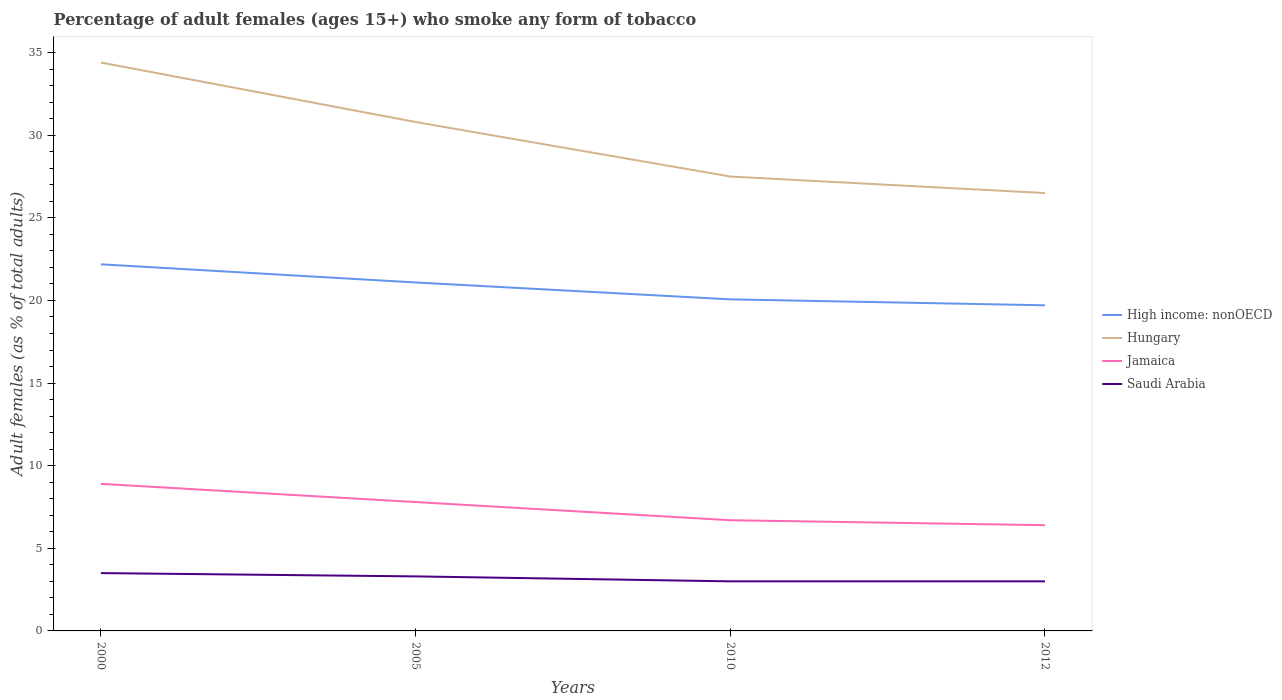Across all years, what is the maximum percentage of adult females who smoke in Jamaica?
Keep it short and to the point. 6.4. In which year was the percentage of adult females who smoke in Saudi Arabia maximum?
Make the answer very short. 2010. What is the total percentage of adult females who smoke in Jamaica in the graph?
Offer a terse response. 0.3. What is the difference between the highest and the lowest percentage of adult females who smoke in High income: nonOECD?
Offer a terse response. 2. Is the percentage of adult females who smoke in High income: nonOECD strictly greater than the percentage of adult females who smoke in Saudi Arabia over the years?
Offer a very short reply. No. How many lines are there?
Provide a short and direct response. 4. What is the difference between two consecutive major ticks on the Y-axis?
Provide a short and direct response. 5. Does the graph contain grids?
Make the answer very short. No. Where does the legend appear in the graph?
Your answer should be compact. Center right. What is the title of the graph?
Keep it short and to the point. Percentage of adult females (ages 15+) who smoke any form of tobacco. What is the label or title of the X-axis?
Your answer should be very brief. Years. What is the label or title of the Y-axis?
Provide a succinct answer. Adult females (as % of total adults). What is the Adult females (as % of total adults) in High income: nonOECD in 2000?
Offer a terse response. 22.19. What is the Adult females (as % of total adults) of Hungary in 2000?
Offer a terse response. 34.4. What is the Adult females (as % of total adults) of Jamaica in 2000?
Give a very brief answer. 8.9. What is the Adult females (as % of total adults) in Saudi Arabia in 2000?
Offer a terse response. 3.5. What is the Adult females (as % of total adults) in High income: nonOECD in 2005?
Ensure brevity in your answer.  21.09. What is the Adult females (as % of total adults) of Hungary in 2005?
Your response must be concise. 30.8. What is the Adult females (as % of total adults) in Jamaica in 2005?
Offer a very short reply. 7.8. What is the Adult females (as % of total adults) in Saudi Arabia in 2005?
Provide a succinct answer. 3.3. What is the Adult females (as % of total adults) in High income: nonOECD in 2010?
Provide a succinct answer. 20.07. What is the Adult females (as % of total adults) in High income: nonOECD in 2012?
Keep it short and to the point. 19.71. What is the Adult females (as % of total adults) of Hungary in 2012?
Your answer should be very brief. 26.5. What is the Adult females (as % of total adults) of Saudi Arabia in 2012?
Offer a very short reply. 3. Across all years, what is the maximum Adult females (as % of total adults) in High income: nonOECD?
Your response must be concise. 22.19. Across all years, what is the maximum Adult females (as % of total adults) in Hungary?
Ensure brevity in your answer.  34.4. Across all years, what is the maximum Adult females (as % of total adults) in Saudi Arabia?
Make the answer very short. 3.5. Across all years, what is the minimum Adult females (as % of total adults) of High income: nonOECD?
Your response must be concise. 19.71. Across all years, what is the minimum Adult females (as % of total adults) in Jamaica?
Give a very brief answer. 6.4. What is the total Adult females (as % of total adults) of High income: nonOECD in the graph?
Your answer should be compact. 83.05. What is the total Adult females (as % of total adults) in Hungary in the graph?
Your response must be concise. 119.2. What is the total Adult females (as % of total adults) of Jamaica in the graph?
Give a very brief answer. 29.8. What is the difference between the Adult females (as % of total adults) of High income: nonOECD in 2000 and that in 2005?
Offer a very short reply. 1.1. What is the difference between the Adult females (as % of total adults) of Saudi Arabia in 2000 and that in 2005?
Offer a very short reply. 0.2. What is the difference between the Adult females (as % of total adults) of High income: nonOECD in 2000 and that in 2010?
Make the answer very short. 2.12. What is the difference between the Adult females (as % of total adults) in Hungary in 2000 and that in 2010?
Give a very brief answer. 6.9. What is the difference between the Adult females (as % of total adults) in Jamaica in 2000 and that in 2010?
Offer a terse response. 2.2. What is the difference between the Adult females (as % of total adults) in Saudi Arabia in 2000 and that in 2010?
Give a very brief answer. 0.5. What is the difference between the Adult females (as % of total adults) in High income: nonOECD in 2000 and that in 2012?
Give a very brief answer. 2.48. What is the difference between the Adult females (as % of total adults) in High income: nonOECD in 2005 and that in 2010?
Provide a short and direct response. 1.02. What is the difference between the Adult females (as % of total adults) of Jamaica in 2005 and that in 2010?
Provide a short and direct response. 1.1. What is the difference between the Adult females (as % of total adults) in High income: nonOECD in 2005 and that in 2012?
Your answer should be very brief. 1.38. What is the difference between the Adult females (as % of total adults) of High income: nonOECD in 2010 and that in 2012?
Your answer should be compact. 0.36. What is the difference between the Adult females (as % of total adults) in Hungary in 2010 and that in 2012?
Make the answer very short. 1. What is the difference between the Adult females (as % of total adults) of Jamaica in 2010 and that in 2012?
Offer a terse response. 0.3. What is the difference between the Adult females (as % of total adults) of High income: nonOECD in 2000 and the Adult females (as % of total adults) of Hungary in 2005?
Provide a succinct answer. -8.61. What is the difference between the Adult females (as % of total adults) in High income: nonOECD in 2000 and the Adult females (as % of total adults) in Jamaica in 2005?
Keep it short and to the point. 14.39. What is the difference between the Adult females (as % of total adults) in High income: nonOECD in 2000 and the Adult females (as % of total adults) in Saudi Arabia in 2005?
Your response must be concise. 18.89. What is the difference between the Adult females (as % of total adults) of Hungary in 2000 and the Adult females (as % of total adults) of Jamaica in 2005?
Offer a terse response. 26.6. What is the difference between the Adult females (as % of total adults) in Hungary in 2000 and the Adult females (as % of total adults) in Saudi Arabia in 2005?
Provide a succinct answer. 31.1. What is the difference between the Adult females (as % of total adults) of Jamaica in 2000 and the Adult females (as % of total adults) of Saudi Arabia in 2005?
Your answer should be very brief. 5.6. What is the difference between the Adult females (as % of total adults) in High income: nonOECD in 2000 and the Adult females (as % of total adults) in Hungary in 2010?
Provide a short and direct response. -5.31. What is the difference between the Adult females (as % of total adults) in High income: nonOECD in 2000 and the Adult females (as % of total adults) in Jamaica in 2010?
Make the answer very short. 15.49. What is the difference between the Adult females (as % of total adults) in High income: nonOECD in 2000 and the Adult females (as % of total adults) in Saudi Arabia in 2010?
Provide a short and direct response. 19.19. What is the difference between the Adult females (as % of total adults) in Hungary in 2000 and the Adult females (as % of total adults) in Jamaica in 2010?
Make the answer very short. 27.7. What is the difference between the Adult females (as % of total adults) in Hungary in 2000 and the Adult females (as % of total adults) in Saudi Arabia in 2010?
Your answer should be very brief. 31.4. What is the difference between the Adult females (as % of total adults) in Jamaica in 2000 and the Adult females (as % of total adults) in Saudi Arabia in 2010?
Give a very brief answer. 5.9. What is the difference between the Adult females (as % of total adults) in High income: nonOECD in 2000 and the Adult females (as % of total adults) in Hungary in 2012?
Give a very brief answer. -4.31. What is the difference between the Adult females (as % of total adults) in High income: nonOECD in 2000 and the Adult females (as % of total adults) in Jamaica in 2012?
Your answer should be very brief. 15.79. What is the difference between the Adult females (as % of total adults) of High income: nonOECD in 2000 and the Adult females (as % of total adults) of Saudi Arabia in 2012?
Make the answer very short. 19.19. What is the difference between the Adult females (as % of total adults) in Hungary in 2000 and the Adult females (as % of total adults) in Jamaica in 2012?
Your answer should be compact. 28. What is the difference between the Adult females (as % of total adults) of Hungary in 2000 and the Adult females (as % of total adults) of Saudi Arabia in 2012?
Give a very brief answer. 31.4. What is the difference between the Adult females (as % of total adults) of High income: nonOECD in 2005 and the Adult females (as % of total adults) of Hungary in 2010?
Keep it short and to the point. -6.41. What is the difference between the Adult females (as % of total adults) in High income: nonOECD in 2005 and the Adult females (as % of total adults) in Jamaica in 2010?
Your answer should be compact. 14.39. What is the difference between the Adult females (as % of total adults) of High income: nonOECD in 2005 and the Adult females (as % of total adults) of Saudi Arabia in 2010?
Your answer should be very brief. 18.09. What is the difference between the Adult females (as % of total adults) in Hungary in 2005 and the Adult females (as % of total adults) in Jamaica in 2010?
Give a very brief answer. 24.1. What is the difference between the Adult females (as % of total adults) of Hungary in 2005 and the Adult females (as % of total adults) of Saudi Arabia in 2010?
Offer a very short reply. 27.8. What is the difference between the Adult females (as % of total adults) of High income: nonOECD in 2005 and the Adult females (as % of total adults) of Hungary in 2012?
Offer a very short reply. -5.41. What is the difference between the Adult females (as % of total adults) in High income: nonOECD in 2005 and the Adult females (as % of total adults) in Jamaica in 2012?
Provide a short and direct response. 14.69. What is the difference between the Adult females (as % of total adults) of High income: nonOECD in 2005 and the Adult females (as % of total adults) of Saudi Arabia in 2012?
Offer a very short reply. 18.09. What is the difference between the Adult females (as % of total adults) in Hungary in 2005 and the Adult females (as % of total adults) in Jamaica in 2012?
Ensure brevity in your answer.  24.4. What is the difference between the Adult females (as % of total adults) of Hungary in 2005 and the Adult females (as % of total adults) of Saudi Arabia in 2012?
Give a very brief answer. 27.8. What is the difference between the Adult females (as % of total adults) of High income: nonOECD in 2010 and the Adult females (as % of total adults) of Hungary in 2012?
Give a very brief answer. -6.43. What is the difference between the Adult females (as % of total adults) in High income: nonOECD in 2010 and the Adult females (as % of total adults) in Jamaica in 2012?
Provide a short and direct response. 13.67. What is the difference between the Adult females (as % of total adults) in High income: nonOECD in 2010 and the Adult females (as % of total adults) in Saudi Arabia in 2012?
Give a very brief answer. 17.07. What is the difference between the Adult females (as % of total adults) of Hungary in 2010 and the Adult females (as % of total adults) of Jamaica in 2012?
Offer a terse response. 21.1. What is the difference between the Adult females (as % of total adults) of Hungary in 2010 and the Adult females (as % of total adults) of Saudi Arabia in 2012?
Give a very brief answer. 24.5. What is the difference between the Adult females (as % of total adults) in Jamaica in 2010 and the Adult females (as % of total adults) in Saudi Arabia in 2012?
Ensure brevity in your answer.  3.7. What is the average Adult females (as % of total adults) of High income: nonOECD per year?
Give a very brief answer. 20.76. What is the average Adult females (as % of total adults) in Hungary per year?
Ensure brevity in your answer.  29.8. What is the average Adult females (as % of total adults) in Jamaica per year?
Provide a short and direct response. 7.45. In the year 2000, what is the difference between the Adult females (as % of total adults) in High income: nonOECD and Adult females (as % of total adults) in Hungary?
Your response must be concise. -12.21. In the year 2000, what is the difference between the Adult females (as % of total adults) in High income: nonOECD and Adult females (as % of total adults) in Jamaica?
Provide a short and direct response. 13.29. In the year 2000, what is the difference between the Adult females (as % of total adults) of High income: nonOECD and Adult females (as % of total adults) of Saudi Arabia?
Provide a short and direct response. 18.69. In the year 2000, what is the difference between the Adult females (as % of total adults) of Hungary and Adult females (as % of total adults) of Saudi Arabia?
Offer a very short reply. 30.9. In the year 2000, what is the difference between the Adult females (as % of total adults) in Jamaica and Adult females (as % of total adults) in Saudi Arabia?
Offer a terse response. 5.4. In the year 2005, what is the difference between the Adult females (as % of total adults) of High income: nonOECD and Adult females (as % of total adults) of Hungary?
Keep it short and to the point. -9.71. In the year 2005, what is the difference between the Adult females (as % of total adults) of High income: nonOECD and Adult females (as % of total adults) of Jamaica?
Give a very brief answer. 13.29. In the year 2005, what is the difference between the Adult females (as % of total adults) in High income: nonOECD and Adult females (as % of total adults) in Saudi Arabia?
Provide a short and direct response. 17.79. In the year 2010, what is the difference between the Adult females (as % of total adults) of High income: nonOECD and Adult females (as % of total adults) of Hungary?
Ensure brevity in your answer.  -7.43. In the year 2010, what is the difference between the Adult females (as % of total adults) in High income: nonOECD and Adult females (as % of total adults) in Jamaica?
Your response must be concise. 13.37. In the year 2010, what is the difference between the Adult females (as % of total adults) of High income: nonOECD and Adult females (as % of total adults) of Saudi Arabia?
Give a very brief answer. 17.07. In the year 2010, what is the difference between the Adult females (as % of total adults) in Hungary and Adult females (as % of total adults) in Jamaica?
Offer a very short reply. 20.8. In the year 2010, what is the difference between the Adult females (as % of total adults) in Jamaica and Adult females (as % of total adults) in Saudi Arabia?
Provide a succinct answer. 3.7. In the year 2012, what is the difference between the Adult females (as % of total adults) of High income: nonOECD and Adult females (as % of total adults) of Hungary?
Make the answer very short. -6.79. In the year 2012, what is the difference between the Adult females (as % of total adults) of High income: nonOECD and Adult females (as % of total adults) of Jamaica?
Ensure brevity in your answer.  13.31. In the year 2012, what is the difference between the Adult females (as % of total adults) of High income: nonOECD and Adult females (as % of total adults) of Saudi Arabia?
Ensure brevity in your answer.  16.71. In the year 2012, what is the difference between the Adult females (as % of total adults) of Hungary and Adult females (as % of total adults) of Jamaica?
Make the answer very short. 20.1. In the year 2012, what is the difference between the Adult females (as % of total adults) in Hungary and Adult females (as % of total adults) in Saudi Arabia?
Make the answer very short. 23.5. In the year 2012, what is the difference between the Adult females (as % of total adults) in Jamaica and Adult females (as % of total adults) in Saudi Arabia?
Give a very brief answer. 3.4. What is the ratio of the Adult females (as % of total adults) of High income: nonOECD in 2000 to that in 2005?
Your answer should be very brief. 1.05. What is the ratio of the Adult females (as % of total adults) in Hungary in 2000 to that in 2005?
Provide a short and direct response. 1.12. What is the ratio of the Adult females (as % of total adults) of Jamaica in 2000 to that in 2005?
Give a very brief answer. 1.14. What is the ratio of the Adult females (as % of total adults) in Saudi Arabia in 2000 to that in 2005?
Ensure brevity in your answer.  1.06. What is the ratio of the Adult females (as % of total adults) in High income: nonOECD in 2000 to that in 2010?
Provide a succinct answer. 1.11. What is the ratio of the Adult females (as % of total adults) in Hungary in 2000 to that in 2010?
Ensure brevity in your answer.  1.25. What is the ratio of the Adult females (as % of total adults) in Jamaica in 2000 to that in 2010?
Ensure brevity in your answer.  1.33. What is the ratio of the Adult females (as % of total adults) in Saudi Arabia in 2000 to that in 2010?
Provide a succinct answer. 1.17. What is the ratio of the Adult females (as % of total adults) of High income: nonOECD in 2000 to that in 2012?
Offer a terse response. 1.13. What is the ratio of the Adult females (as % of total adults) of Hungary in 2000 to that in 2012?
Your response must be concise. 1.3. What is the ratio of the Adult females (as % of total adults) in Jamaica in 2000 to that in 2012?
Your answer should be very brief. 1.39. What is the ratio of the Adult females (as % of total adults) in High income: nonOECD in 2005 to that in 2010?
Make the answer very short. 1.05. What is the ratio of the Adult females (as % of total adults) in Hungary in 2005 to that in 2010?
Ensure brevity in your answer.  1.12. What is the ratio of the Adult females (as % of total adults) of Jamaica in 2005 to that in 2010?
Your answer should be very brief. 1.16. What is the ratio of the Adult females (as % of total adults) in High income: nonOECD in 2005 to that in 2012?
Keep it short and to the point. 1.07. What is the ratio of the Adult females (as % of total adults) in Hungary in 2005 to that in 2012?
Ensure brevity in your answer.  1.16. What is the ratio of the Adult females (as % of total adults) in Jamaica in 2005 to that in 2012?
Ensure brevity in your answer.  1.22. What is the ratio of the Adult females (as % of total adults) of Saudi Arabia in 2005 to that in 2012?
Keep it short and to the point. 1.1. What is the ratio of the Adult females (as % of total adults) of High income: nonOECD in 2010 to that in 2012?
Your answer should be very brief. 1.02. What is the ratio of the Adult females (as % of total adults) of Hungary in 2010 to that in 2012?
Provide a succinct answer. 1.04. What is the ratio of the Adult females (as % of total adults) of Jamaica in 2010 to that in 2012?
Keep it short and to the point. 1.05. What is the ratio of the Adult females (as % of total adults) of Saudi Arabia in 2010 to that in 2012?
Give a very brief answer. 1. What is the difference between the highest and the second highest Adult females (as % of total adults) in High income: nonOECD?
Provide a succinct answer. 1.1. What is the difference between the highest and the second highest Adult females (as % of total adults) in Hungary?
Your response must be concise. 3.6. What is the difference between the highest and the second highest Adult females (as % of total adults) of Saudi Arabia?
Give a very brief answer. 0.2. What is the difference between the highest and the lowest Adult females (as % of total adults) in High income: nonOECD?
Provide a succinct answer. 2.48. What is the difference between the highest and the lowest Adult females (as % of total adults) of Jamaica?
Provide a short and direct response. 2.5. 